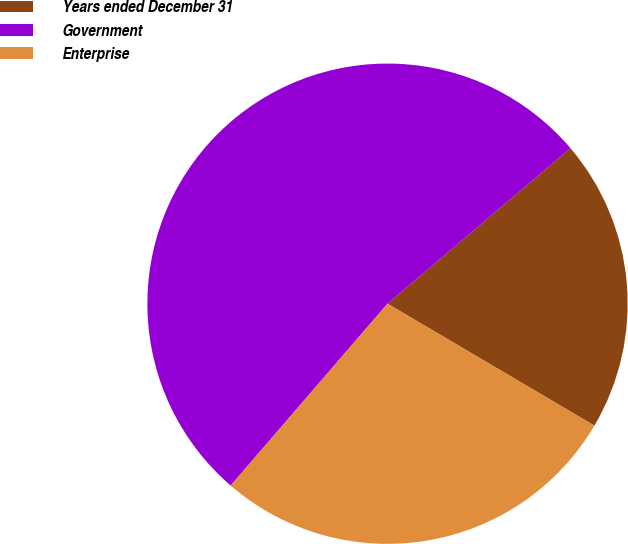<chart> <loc_0><loc_0><loc_500><loc_500><pie_chart><fcel>Years ended December 31<fcel>Government<fcel>Enterprise<nl><fcel>19.69%<fcel>52.46%<fcel>27.85%<nl></chart> 